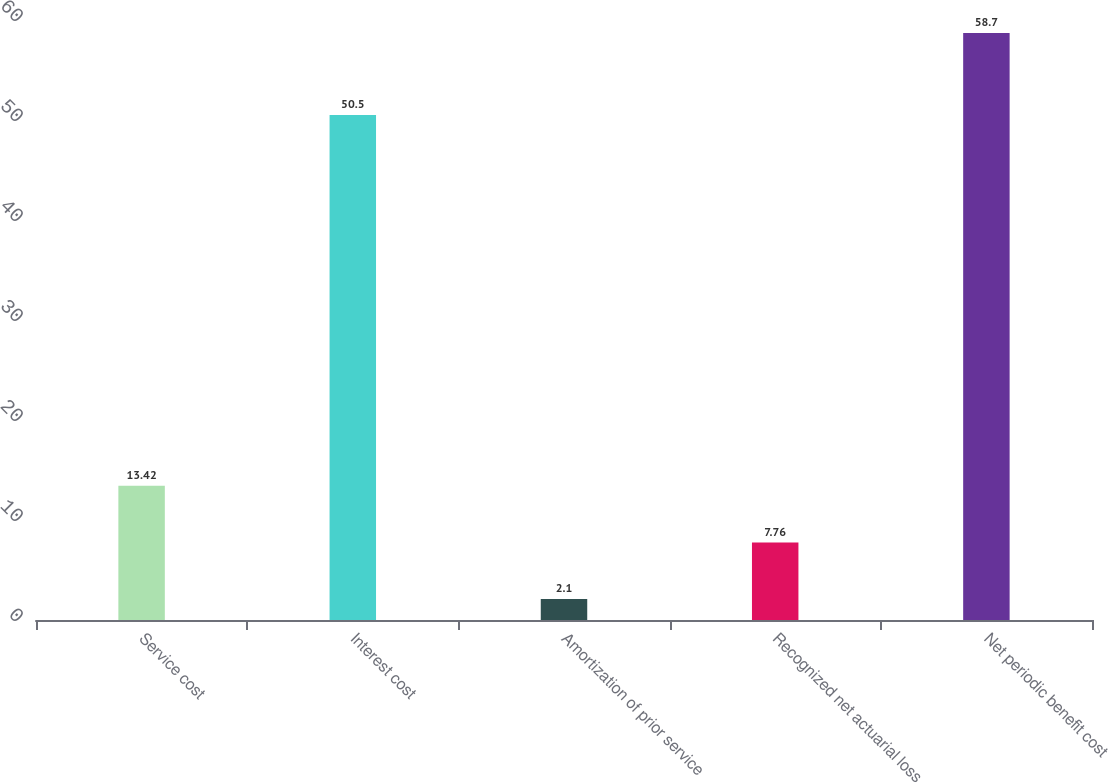Convert chart. <chart><loc_0><loc_0><loc_500><loc_500><bar_chart><fcel>Service cost<fcel>Interest cost<fcel>Amortization of prior service<fcel>Recognized net actuarial loss<fcel>Net periodic benefit cost<nl><fcel>13.42<fcel>50.5<fcel>2.1<fcel>7.76<fcel>58.7<nl></chart> 